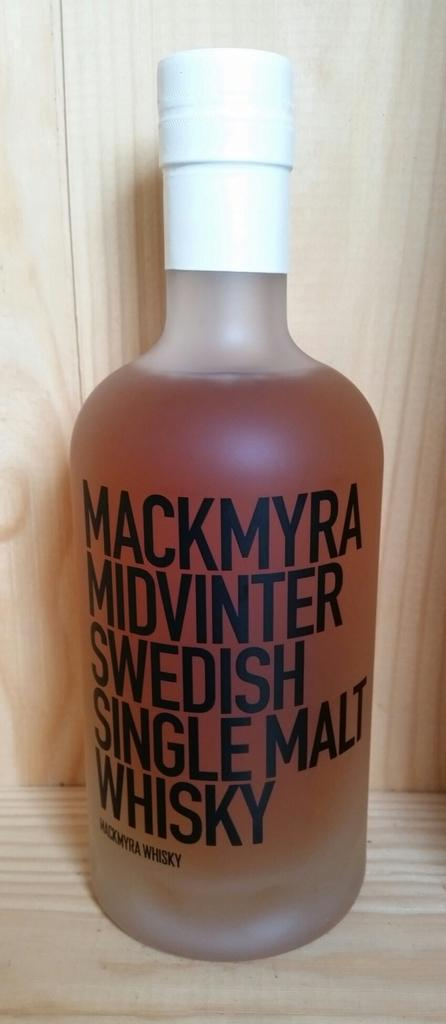<image>
Render a clear and concise summary of the photo. A bottle of Mackmyra whisky has a white cap. 